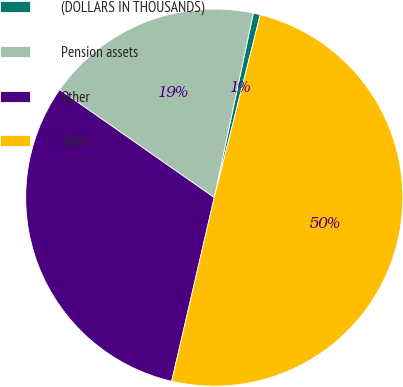<chart> <loc_0><loc_0><loc_500><loc_500><pie_chart><fcel>(DOLLARS IN THOUSANDS)<fcel>Pension assets<fcel>Other<fcel>Total<nl><fcel>0.6%<fcel>18.62%<fcel>31.08%<fcel>49.7%<nl></chart> 